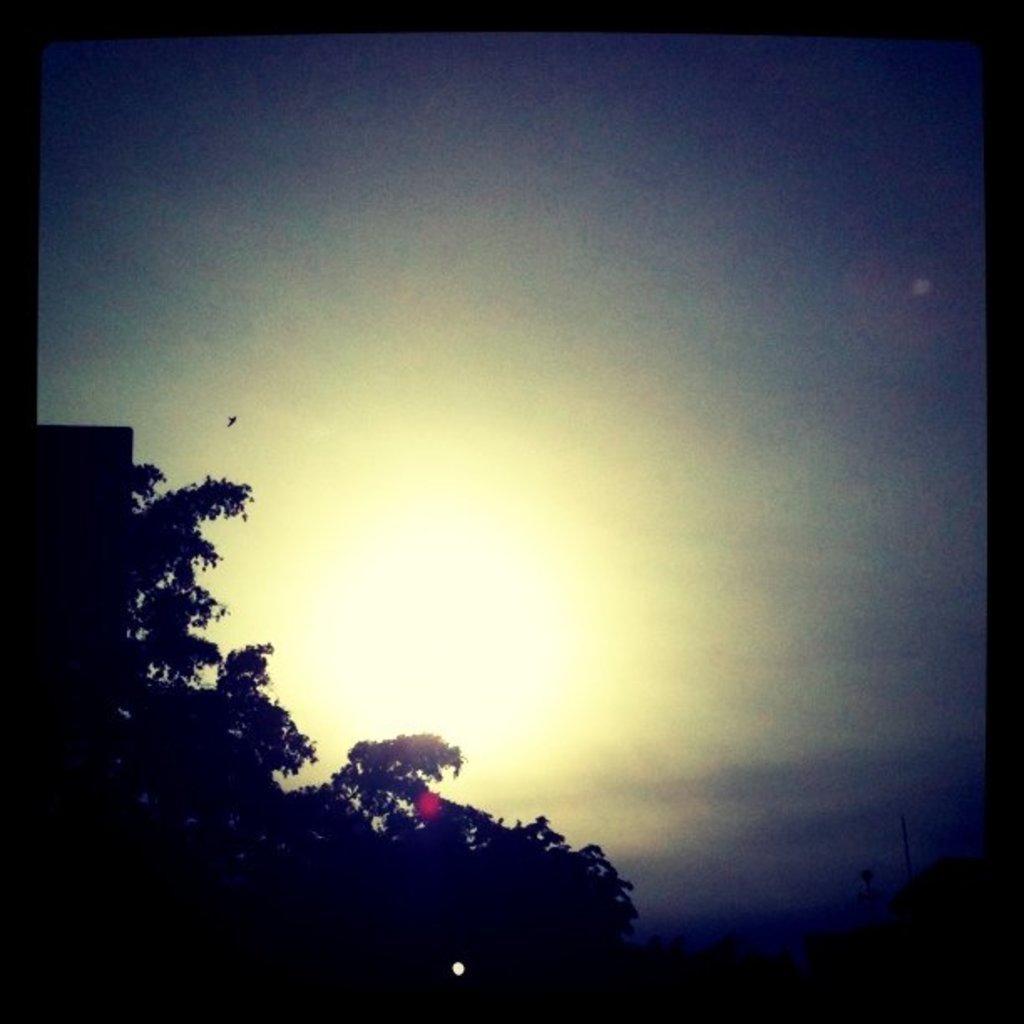In one or two sentences, can you explain what this image depicts? In the image there are trees on the left side and above its sky. 